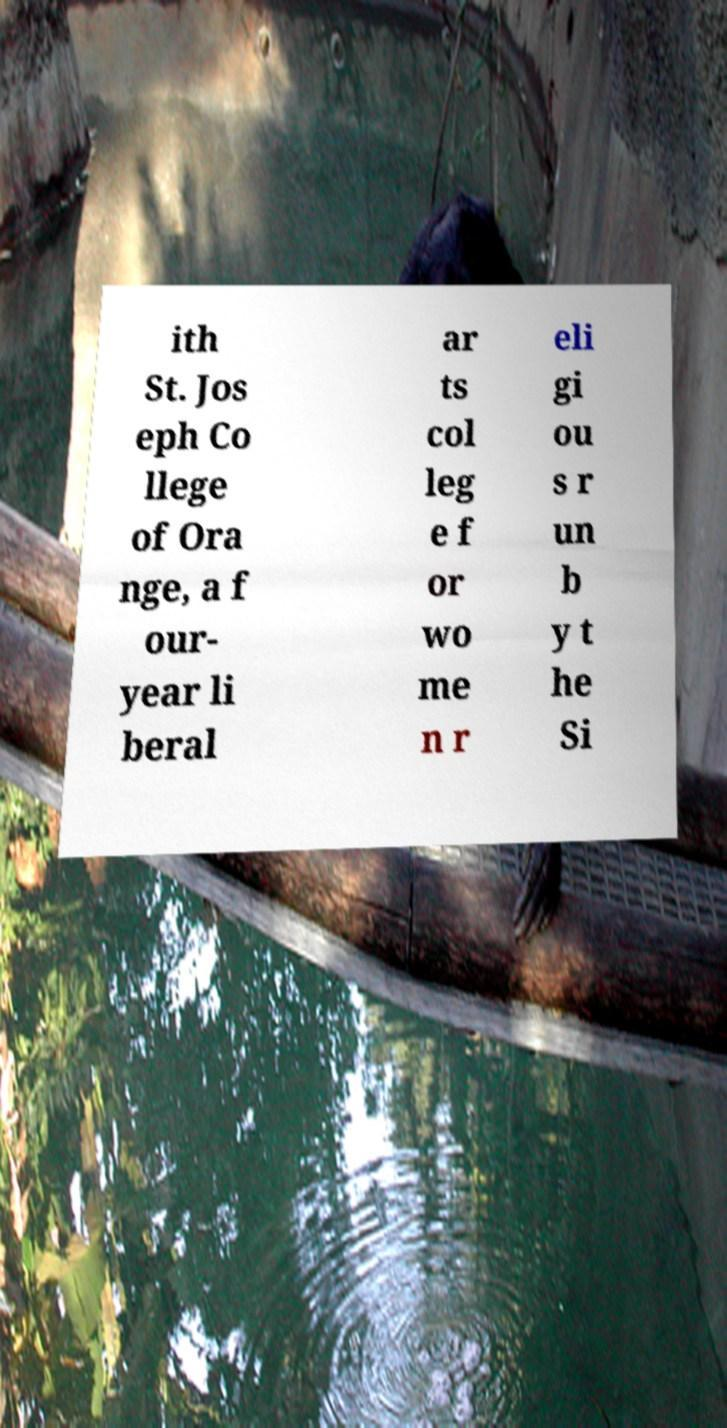Can you accurately transcribe the text from the provided image for me? ith St. Jos eph Co llege of Ora nge, a f our- year li beral ar ts col leg e f or wo me n r eli gi ou s r un b y t he Si 